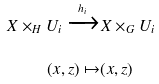<formula> <loc_0><loc_0><loc_500><loc_500>X \times _ { H } U _ { i } \xrightarrow { h _ { i } } & X \times _ { G } U _ { i } \\ ( x , z ) \mapsto & ( x , z )</formula> 